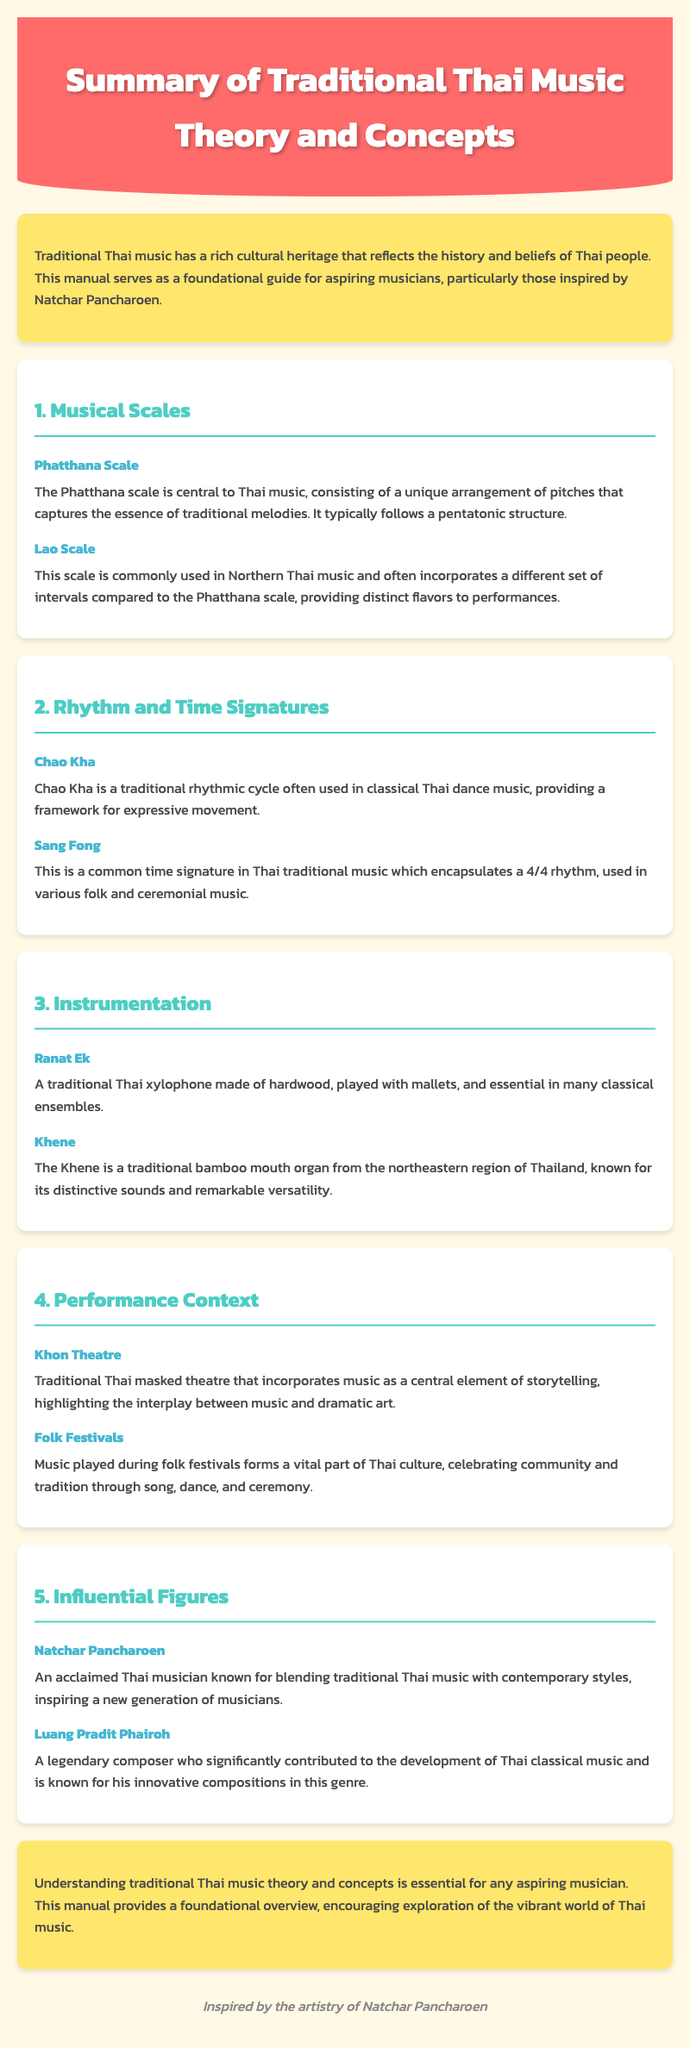What is the central scale in Thai music? The Phatthana scale is central to Thai music, consisting of a unique arrangement of pitches.
Answer: Phatthana scale What rhythmic cycle is used in classical Thai dance music? Chao Kha is a traditional rhythmic cycle often used in classical Thai dance music.
Answer: Chao Kha What type of instrument is the Ranat Ek? The Ranat Ek is a traditional Thai xylophone made of hardwood.
Answer: Xylophone Which traditional theatre incorporates music into storytelling? Khon Theatre is a traditional Thai masked theatre that incorporates music as a central element of storytelling.
Answer: Khon Theatre Who is known for blending traditional Thai music with contemporary styles? Natchar Pancharoen is known for blending traditional Thai music with contemporary styles.
Answer: Natchar Pancharoen What is the time signature used in various folk and ceremonial music? Sang Fong is a common time signature in Thai traditional music which encapsulates a 4/4 rhythm.
Answer: 4/4 What is the Khene made of? The Khene is a traditional bamboo mouth organ from the northeastern region of Thailand.
Answer: Bamboo What does traditional Thai music celebrate during folk festivals? Music played during folk festivals celebrates community and tradition.
Answer: Community and tradition What is emphasized in the development of Thai classical music according to Luang Pradit Phairoh? Luang Pradit Phairoh significantly contributed to the development of Thai classical music.
Answer: Development of Thai classical music 